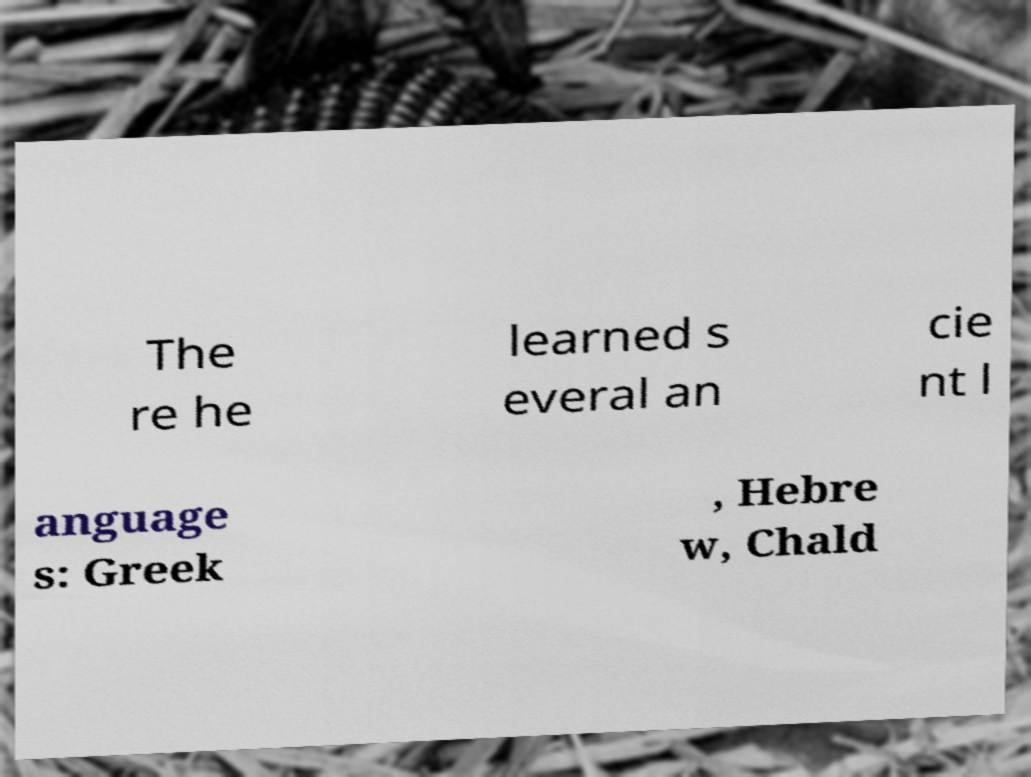Please read and relay the text visible in this image. What does it say? The re he learned s everal an cie nt l anguage s: Greek , Hebre w, Chald 